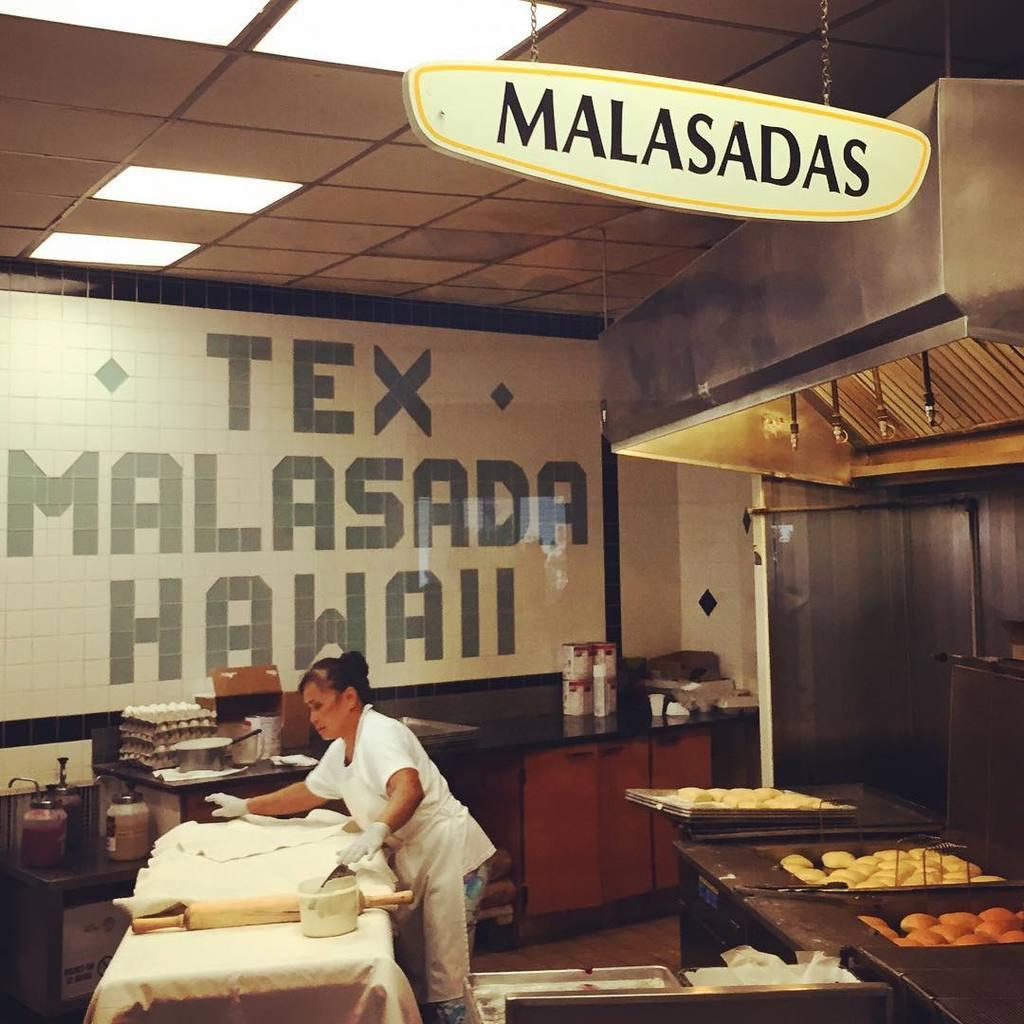Can you describe this image briefly? In this picture we can see a woman who is standing on the floor. This is the table. On the table there is a cloth. This is some food. On the background there are cupboards. And this is the wall and these are the lights. 